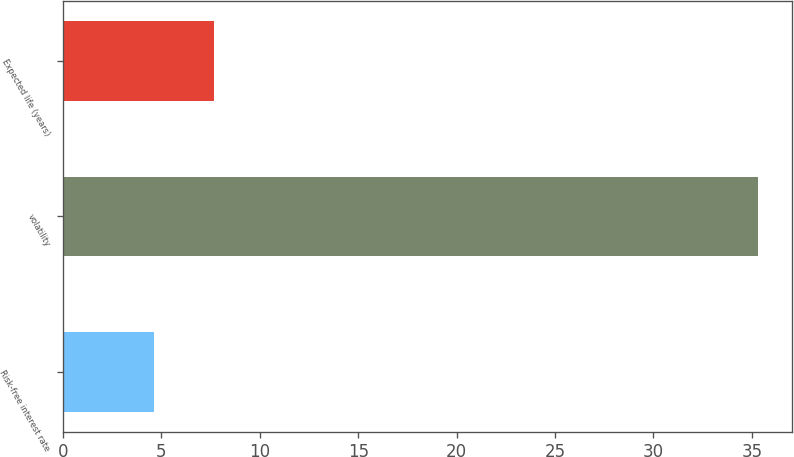Convert chart. <chart><loc_0><loc_0><loc_500><loc_500><bar_chart><fcel>Risk-free interest rate<fcel>volatility<fcel>Expected life (years)<nl><fcel>4.6<fcel>35.3<fcel>7.67<nl></chart> 